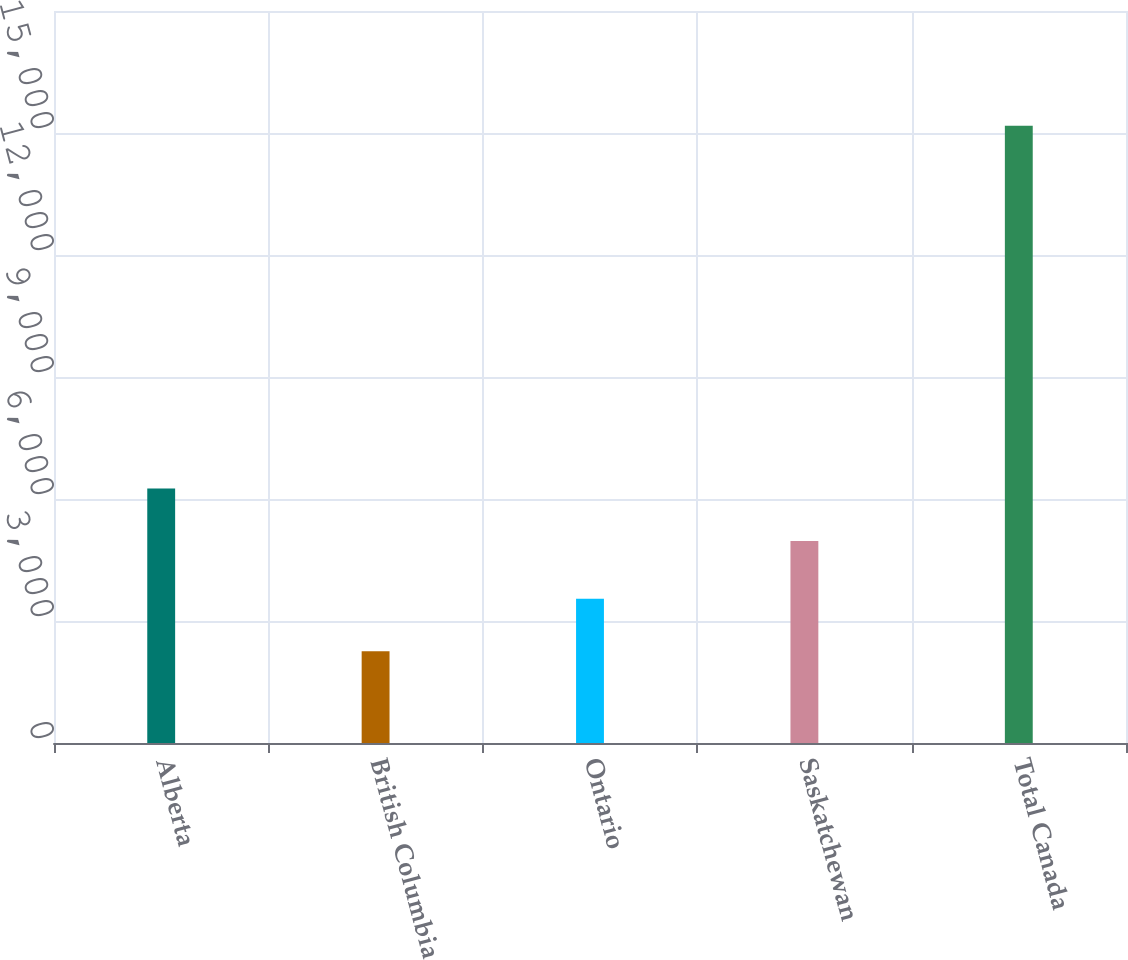Convert chart to OTSL. <chart><loc_0><loc_0><loc_500><loc_500><bar_chart><fcel>Alberta<fcel>British Columbia<fcel>Ontario<fcel>Saskatchewan<fcel>Total Canada<nl><fcel>6260.2<fcel>2255<fcel>3547.2<fcel>4968<fcel>15177<nl></chart> 